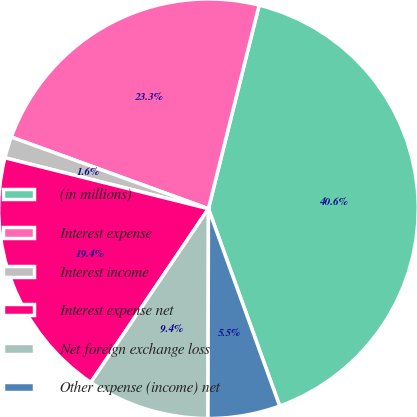<chart> <loc_0><loc_0><loc_500><loc_500><pie_chart><fcel>(in millions)<fcel>Interest expense<fcel>Interest income<fcel>Interest expense net<fcel>Net foreign exchange loss<fcel>Other expense (income) net<nl><fcel>40.6%<fcel>23.33%<fcel>1.65%<fcel>19.43%<fcel>9.44%<fcel>5.55%<nl></chart> 